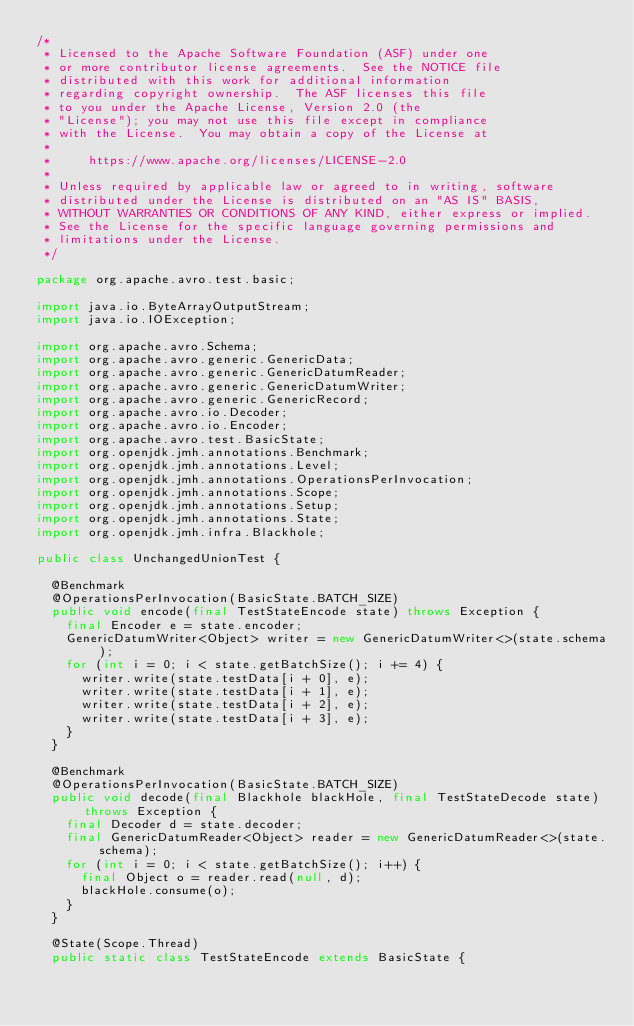Convert code to text. <code><loc_0><loc_0><loc_500><loc_500><_Java_>/*
 * Licensed to the Apache Software Foundation (ASF) under one
 * or more contributor license agreements.  See the NOTICE file
 * distributed with this work for additional information
 * regarding copyright ownership.  The ASF licenses this file
 * to you under the Apache License, Version 2.0 (the
 * "License"); you may not use this file except in compliance
 * with the License.  You may obtain a copy of the License at
 *
 *     https://www.apache.org/licenses/LICENSE-2.0
 *
 * Unless required by applicable law or agreed to in writing, software
 * distributed under the License is distributed on an "AS IS" BASIS,
 * WITHOUT WARRANTIES OR CONDITIONS OF ANY KIND, either express or implied.
 * See the License for the specific language governing permissions and
 * limitations under the License.
 */

package org.apache.avro.test.basic;

import java.io.ByteArrayOutputStream;
import java.io.IOException;

import org.apache.avro.Schema;
import org.apache.avro.generic.GenericData;
import org.apache.avro.generic.GenericDatumReader;
import org.apache.avro.generic.GenericDatumWriter;
import org.apache.avro.generic.GenericRecord;
import org.apache.avro.io.Decoder;
import org.apache.avro.io.Encoder;
import org.apache.avro.test.BasicState;
import org.openjdk.jmh.annotations.Benchmark;
import org.openjdk.jmh.annotations.Level;
import org.openjdk.jmh.annotations.OperationsPerInvocation;
import org.openjdk.jmh.annotations.Scope;
import org.openjdk.jmh.annotations.Setup;
import org.openjdk.jmh.annotations.State;
import org.openjdk.jmh.infra.Blackhole;

public class UnchangedUnionTest {

  @Benchmark
  @OperationsPerInvocation(BasicState.BATCH_SIZE)
  public void encode(final TestStateEncode state) throws Exception {
    final Encoder e = state.encoder;
    GenericDatumWriter<Object> writer = new GenericDatumWriter<>(state.schema);
    for (int i = 0; i < state.getBatchSize(); i += 4) {
      writer.write(state.testData[i + 0], e);
      writer.write(state.testData[i + 1], e);
      writer.write(state.testData[i + 2], e);
      writer.write(state.testData[i + 3], e);
    }
  }

  @Benchmark
  @OperationsPerInvocation(BasicState.BATCH_SIZE)
  public void decode(final Blackhole blackHole, final TestStateDecode state) throws Exception {
    final Decoder d = state.decoder;
    final GenericDatumReader<Object> reader = new GenericDatumReader<>(state.schema);
    for (int i = 0; i < state.getBatchSize(); i++) {
      final Object o = reader.read(null, d);
      blackHole.consume(o);
    }
  }

  @State(Scope.Thread)
  public static class TestStateEncode extends BasicState {</code> 